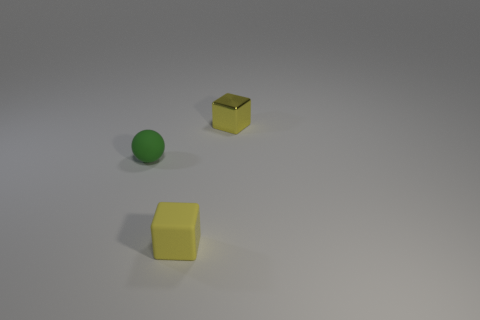There is a tiny thing left of the yellow thing in front of the green ball; is there a tiny matte sphere behind it?
Keep it short and to the point. No. There is a metal thing that is the same size as the green ball; what is its shape?
Your response must be concise. Cube. How many small things are yellow metal things or yellow rubber things?
Offer a very short reply. 2. What is the color of the small block that is the same material as the small green sphere?
Keep it short and to the point. Yellow. There is a small thing that is behind the small green matte ball; is its shape the same as the small yellow thing in front of the yellow shiny object?
Your answer should be very brief. Yes. How many matte objects are either cubes or small green spheres?
Offer a very short reply. 2. What is the material of the tiny cube that is the same color as the metal thing?
Make the answer very short. Rubber. Are there any other things that are the same shape as the tiny yellow shiny object?
Keep it short and to the point. Yes. There is a yellow block behind the small sphere; what is it made of?
Offer a terse response. Metal. Do the small yellow object in front of the tiny green matte object and the green object have the same material?
Your response must be concise. Yes. 